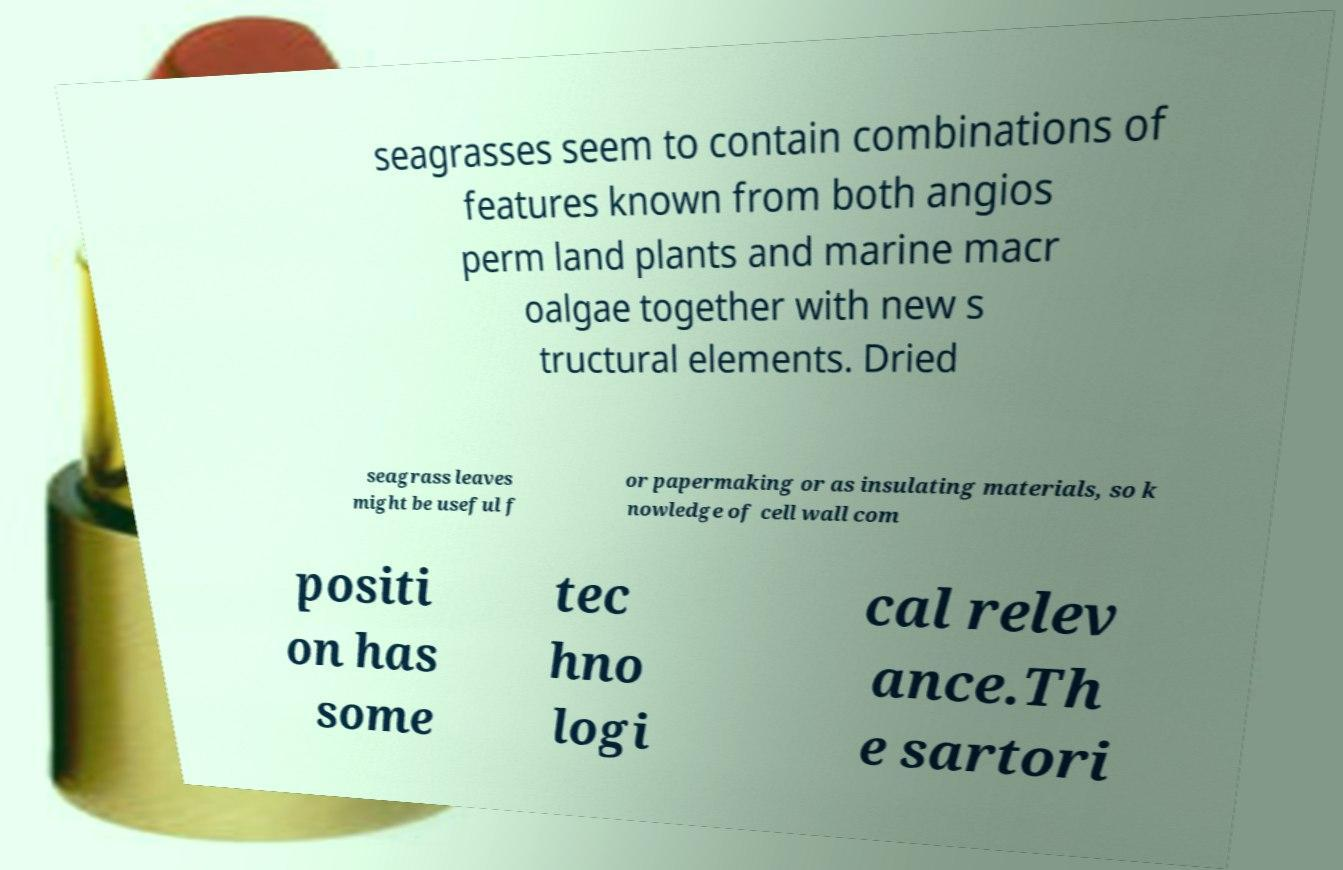What messages or text are displayed in this image? I need them in a readable, typed format. seagrasses seem to contain combinations of features known from both angios perm land plants and marine macr oalgae together with new s tructural elements. Dried seagrass leaves might be useful f or papermaking or as insulating materials, so k nowledge of cell wall com positi on has some tec hno logi cal relev ance.Th e sartori 